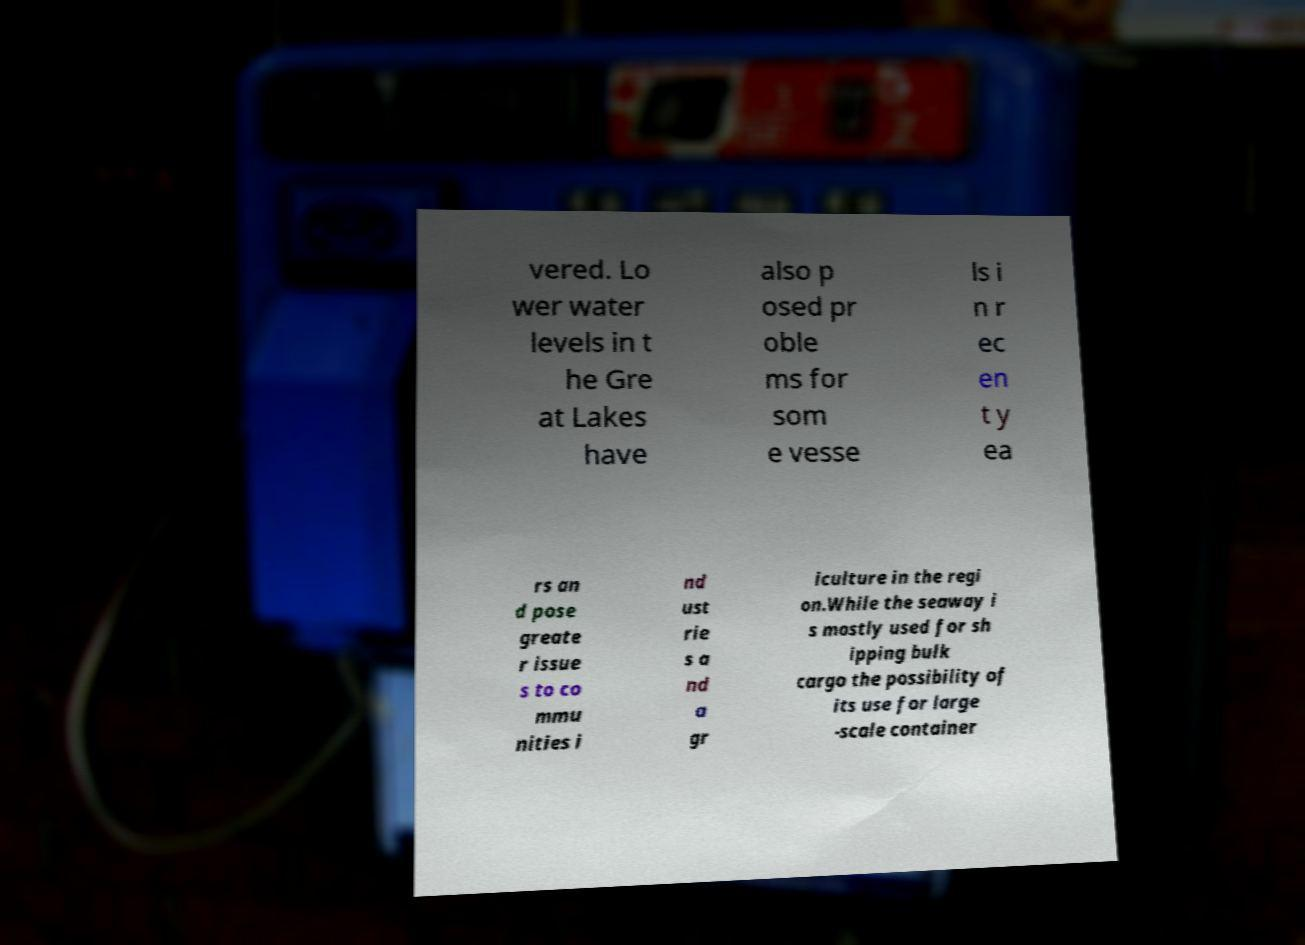Can you read and provide the text displayed in the image?This photo seems to have some interesting text. Can you extract and type it out for me? vered. Lo wer water levels in t he Gre at Lakes have also p osed pr oble ms for som e vesse ls i n r ec en t y ea rs an d pose greate r issue s to co mmu nities i nd ust rie s a nd a gr iculture in the regi on.While the seaway i s mostly used for sh ipping bulk cargo the possibility of its use for large -scale container 